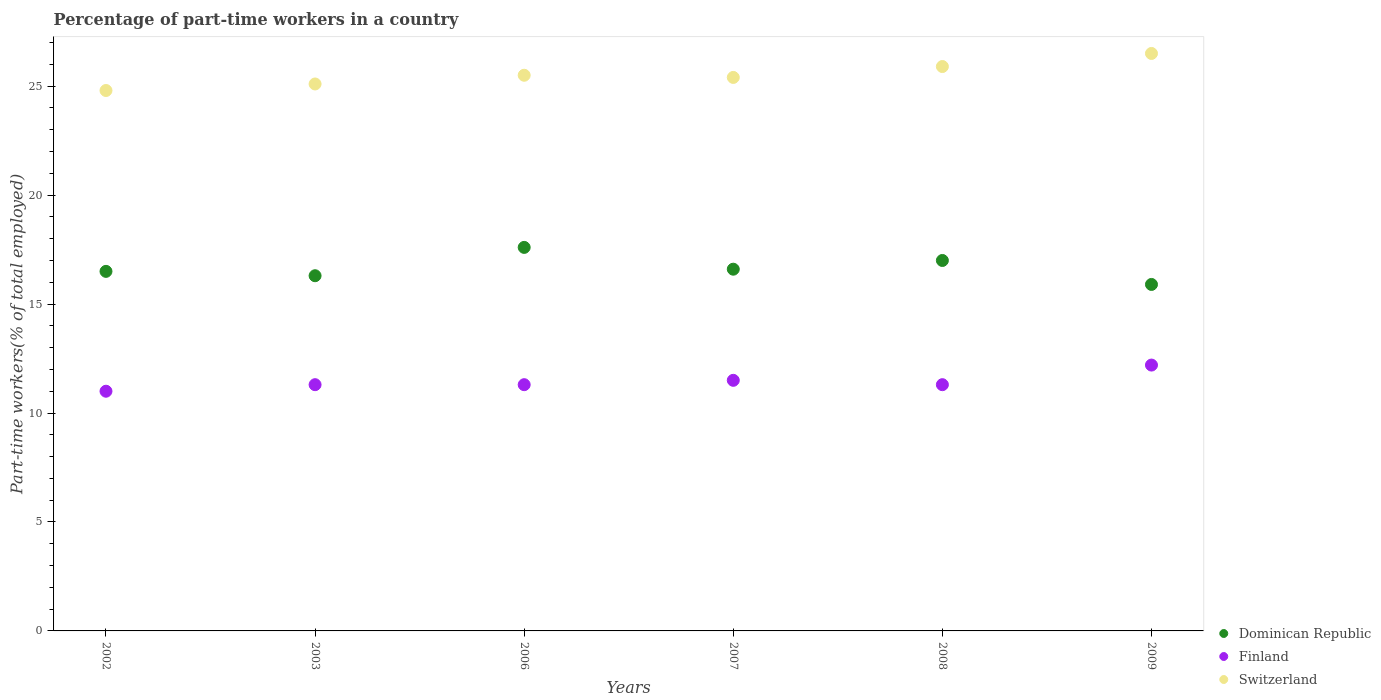Is the number of dotlines equal to the number of legend labels?
Offer a terse response. Yes. What is the percentage of part-time workers in Finland in 2003?
Give a very brief answer. 11.3. Across all years, what is the minimum percentage of part-time workers in Dominican Republic?
Your response must be concise. 15.9. In which year was the percentage of part-time workers in Switzerland maximum?
Keep it short and to the point. 2009. What is the total percentage of part-time workers in Finland in the graph?
Keep it short and to the point. 68.6. What is the difference between the percentage of part-time workers in Dominican Republic in 2003 and that in 2007?
Your answer should be very brief. -0.3. What is the difference between the percentage of part-time workers in Finland in 2002 and the percentage of part-time workers in Switzerland in 2008?
Your answer should be compact. -14.9. What is the average percentage of part-time workers in Finland per year?
Make the answer very short. 11.43. In the year 2003, what is the difference between the percentage of part-time workers in Dominican Republic and percentage of part-time workers in Switzerland?
Keep it short and to the point. -8.8. In how many years, is the percentage of part-time workers in Dominican Republic greater than 18 %?
Provide a succinct answer. 0. What is the ratio of the percentage of part-time workers in Finland in 2002 to that in 2003?
Offer a very short reply. 0.97. What is the difference between the highest and the second highest percentage of part-time workers in Dominican Republic?
Your answer should be very brief. 0.6. What is the difference between the highest and the lowest percentage of part-time workers in Switzerland?
Make the answer very short. 1.7. Is the percentage of part-time workers in Switzerland strictly greater than the percentage of part-time workers in Finland over the years?
Offer a terse response. Yes. Is the percentage of part-time workers in Dominican Republic strictly less than the percentage of part-time workers in Switzerland over the years?
Keep it short and to the point. Yes. Are the values on the major ticks of Y-axis written in scientific E-notation?
Your answer should be compact. No. Does the graph contain grids?
Your answer should be compact. No. How many legend labels are there?
Ensure brevity in your answer.  3. How are the legend labels stacked?
Your response must be concise. Vertical. What is the title of the graph?
Provide a succinct answer. Percentage of part-time workers in a country. Does "Senegal" appear as one of the legend labels in the graph?
Your response must be concise. No. What is the label or title of the X-axis?
Provide a succinct answer. Years. What is the label or title of the Y-axis?
Provide a short and direct response. Part-time workers(% of total employed). What is the Part-time workers(% of total employed) in Dominican Republic in 2002?
Give a very brief answer. 16.5. What is the Part-time workers(% of total employed) of Switzerland in 2002?
Give a very brief answer. 24.8. What is the Part-time workers(% of total employed) of Dominican Republic in 2003?
Offer a terse response. 16.3. What is the Part-time workers(% of total employed) of Finland in 2003?
Your answer should be very brief. 11.3. What is the Part-time workers(% of total employed) in Switzerland in 2003?
Give a very brief answer. 25.1. What is the Part-time workers(% of total employed) in Dominican Republic in 2006?
Your answer should be compact. 17.6. What is the Part-time workers(% of total employed) in Finland in 2006?
Make the answer very short. 11.3. What is the Part-time workers(% of total employed) in Dominican Republic in 2007?
Your answer should be compact. 16.6. What is the Part-time workers(% of total employed) of Finland in 2007?
Give a very brief answer. 11.5. What is the Part-time workers(% of total employed) of Switzerland in 2007?
Your response must be concise. 25.4. What is the Part-time workers(% of total employed) in Dominican Republic in 2008?
Provide a short and direct response. 17. What is the Part-time workers(% of total employed) in Finland in 2008?
Give a very brief answer. 11.3. What is the Part-time workers(% of total employed) of Switzerland in 2008?
Give a very brief answer. 25.9. What is the Part-time workers(% of total employed) in Dominican Republic in 2009?
Ensure brevity in your answer.  15.9. What is the Part-time workers(% of total employed) in Finland in 2009?
Your answer should be compact. 12.2. Across all years, what is the maximum Part-time workers(% of total employed) of Dominican Republic?
Provide a short and direct response. 17.6. Across all years, what is the maximum Part-time workers(% of total employed) of Finland?
Provide a succinct answer. 12.2. Across all years, what is the minimum Part-time workers(% of total employed) of Dominican Republic?
Your answer should be very brief. 15.9. Across all years, what is the minimum Part-time workers(% of total employed) in Switzerland?
Offer a terse response. 24.8. What is the total Part-time workers(% of total employed) in Dominican Republic in the graph?
Offer a terse response. 99.9. What is the total Part-time workers(% of total employed) of Finland in the graph?
Make the answer very short. 68.6. What is the total Part-time workers(% of total employed) of Switzerland in the graph?
Offer a terse response. 153.2. What is the difference between the Part-time workers(% of total employed) in Dominican Republic in 2002 and that in 2003?
Your response must be concise. 0.2. What is the difference between the Part-time workers(% of total employed) of Finland in 2002 and that in 2006?
Ensure brevity in your answer.  -0.3. What is the difference between the Part-time workers(% of total employed) in Finland in 2002 and that in 2007?
Your response must be concise. -0.5. What is the difference between the Part-time workers(% of total employed) of Switzerland in 2002 and that in 2007?
Keep it short and to the point. -0.6. What is the difference between the Part-time workers(% of total employed) of Dominican Republic in 2002 and that in 2008?
Offer a very short reply. -0.5. What is the difference between the Part-time workers(% of total employed) in Switzerland in 2002 and that in 2008?
Give a very brief answer. -1.1. What is the difference between the Part-time workers(% of total employed) of Dominican Republic in 2002 and that in 2009?
Ensure brevity in your answer.  0.6. What is the difference between the Part-time workers(% of total employed) in Finland in 2003 and that in 2006?
Keep it short and to the point. 0. What is the difference between the Part-time workers(% of total employed) of Switzerland in 2003 and that in 2006?
Your response must be concise. -0.4. What is the difference between the Part-time workers(% of total employed) in Dominican Republic in 2003 and that in 2008?
Give a very brief answer. -0.7. What is the difference between the Part-time workers(% of total employed) in Finland in 2003 and that in 2009?
Your response must be concise. -0.9. What is the difference between the Part-time workers(% of total employed) in Switzerland in 2003 and that in 2009?
Your answer should be compact. -1.4. What is the difference between the Part-time workers(% of total employed) in Dominican Republic in 2006 and that in 2007?
Keep it short and to the point. 1. What is the difference between the Part-time workers(% of total employed) in Switzerland in 2006 and that in 2007?
Offer a terse response. 0.1. What is the difference between the Part-time workers(% of total employed) of Switzerland in 2006 and that in 2008?
Your response must be concise. -0.4. What is the difference between the Part-time workers(% of total employed) of Switzerland in 2006 and that in 2009?
Ensure brevity in your answer.  -1. What is the difference between the Part-time workers(% of total employed) in Finland in 2007 and that in 2008?
Provide a short and direct response. 0.2. What is the difference between the Part-time workers(% of total employed) of Switzerland in 2007 and that in 2008?
Make the answer very short. -0.5. What is the difference between the Part-time workers(% of total employed) in Dominican Republic in 2007 and that in 2009?
Offer a terse response. 0.7. What is the difference between the Part-time workers(% of total employed) in Finland in 2007 and that in 2009?
Ensure brevity in your answer.  -0.7. What is the difference between the Part-time workers(% of total employed) of Switzerland in 2007 and that in 2009?
Offer a terse response. -1.1. What is the difference between the Part-time workers(% of total employed) in Dominican Republic in 2008 and that in 2009?
Provide a short and direct response. 1.1. What is the difference between the Part-time workers(% of total employed) in Switzerland in 2008 and that in 2009?
Provide a succinct answer. -0.6. What is the difference between the Part-time workers(% of total employed) of Dominican Republic in 2002 and the Part-time workers(% of total employed) of Finland in 2003?
Offer a very short reply. 5.2. What is the difference between the Part-time workers(% of total employed) of Finland in 2002 and the Part-time workers(% of total employed) of Switzerland in 2003?
Ensure brevity in your answer.  -14.1. What is the difference between the Part-time workers(% of total employed) in Dominican Republic in 2002 and the Part-time workers(% of total employed) in Switzerland in 2006?
Your answer should be very brief. -9. What is the difference between the Part-time workers(% of total employed) of Finland in 2002 and the Part-time workers(% of total employed) of Switzerland in 2006?
Ensure brevity in your answer.  -14.5. What is the difference between the Part-time workers(% of total employed) in Dominican Republic in 2002 and the Part-time workers(% of total employed) in Switzerland in 2007?
Your answer should be very brief. -8.9. What is the difference between the Part-time workers(% of total employed) in Finland in 2002 and the Part-time workers(% of total employed) in Switzerland in 2007?
Your answer should be compact. -14.4. What is the difference between the Part-time workers(% of total employed) in Dominican Republic in 2002 and the Part-time workers(% of total employed) in Finland in 2008?
Ensure brevity in your answer.  5.2. What is the difference between the Part-time workers(% of total employed) of Dominican Republic in 2002 and the Part-time workers(% of total employed) of Switzerland in 2008?
Ensure brevity in your answer.  -9.4. What is the difference between the Part-time workers(% of total employed) in Finland in 2002 and the Part-time workers(% of total employed) in Switzerland in 2008?
Keep it short and to the point. -14.9. What is the difference between the Part-time workers(% of total employed) in Dominican Republic in 2002 and the Part-time workers(% of total employed) in Switzerland in 2009?
Offer a very short reply. -10. What is the difference between the Part-time workers(% of total employed) of Finland in 2002 and the Part-time workers(% of total employed) of Switzerland in 2009?
Keep it short and to the point. -15.5. What is the difference between the Part-time workers(% of total employed) of Dominican Republic in 2003 and the Part-time workers(% of total employed) of Switzerland in 2006?
Your answer should be very brief. -9.2. What is the difference between the Part-time workers(% of total employed) of Dominican Republic in 2003 and the Part-time workers(% of total employed) of Switzerland in 2007?
Your response must be concise. -9.1. What is the difference between the Part-time workers(% of total employed) in Finland in 2003 and the Part-time workers(% of total employed) in Switzerland in 2007?
Give a very brief answer. -14.1. What is the difference between the Part-time workers(% of total employed) in Finland in 2003 and the Part-time workers(% of total employed) in Switzerland in 2008?
Your answer should be compact. -14.6. What is the difference between the Part-time workers(% of total employed) in Dominican Republic in 2003 and the Part-time workers(% of total employed) in Finland in 2009?
Provide a short and direct response. 4.1. What is the difference between the Part-time workers(% of total employed) in Dominican Republic in 2003 and the Part-time workers(% of total employed) in Switzerland in 2009?
Provide a short and direct response. -10.2. What is the difference between the Part-time workers(% of total employed) in Finland in 2003 and the Part-time workers(% of total employed) in Switzerland in 2009?
Make the answer very short. -15.2. What is the difference between the Part-time workers(% of total employed) of Dominican Republic in 2006 and the Part-time workers(% of total employed) of Finland in 2007?
Offer a terse response. 6.1. What is the difference between the Part-time workers(% of total employed) of Finland in 2006 and the Part-time workers(% of total employed) of Switzerland in 2007?
Give a very brief answer. -14.1. What is the difference between the Part-time workers(% of total employed) of Dominican Republic in 2006 and the Part-time workers(% of total employed) of Switzerland in 2008?
Your response must be concise. -8.3. What is the difference between the Part-time workers(% of total employed) in Finland in 2006 and the Part-time workers(% of total employed) in Switzerland in 2008?
Your answer should be very brief. -14.6. What is the difference between the Part-time workers(% of total employed) of Dominican Republic in 2006 and the Part-time workers(% of total employed) of Finland in 2009?
Offer a terse response. 5.4. What is the difference between the Part-time workers(% of total employed) in Dominican Republic in 2006 and the Part-time workers(% of total employed) in Switzerland in 2009?
Your response must be concise. -8.9. What is the difference between the Part-time workers(% of total employed) of Finland in 2006 and the Part-time workers(% of total employed) of Switzerland in 2009?
Provide a succinct answer. -15.2. What is the difference between the Part-time workers(% of total employed) of Dominican Republic in 2007 and the Part-time workers(% of total employed) of Finland in 2008?
Your answer should be compact. 5.3. What is the difference between the Part-time workers(% of total employed) in Finland in 2007 and the Part-time workers(% of total employed) in Switzerland in 2008?
Offer a terse response. -14.4. What is the difference between the Part-time workers(% of total employed) of Dominican Republic in 2007 and the Part-time workers(% of total employed) of Finland in 2009?
Give a very brief answer. 4.4. What is the difference between the Part-time workers(% of total employed) in Finland in 2007 and the Part-time workers(% of total employed) in Switzerland in 2009?
Ensure brevity in your answer.  -15. What is the difference between the Part-time workers(% of total employed) in Dominican Republic in 2008 and the Part-time workers(% of total employed) in Finland in 2009?
Ensure brevity in your answer.  4.8. What is the difference between the Part-time workers(% of total employed) of Dominican Republic in 2008 and the Part-time workers(% of total employed) of Switzerland in 2009?
Your answer should be compact. -9.5. What is the difference between the Part-time workers(% of total employed) of Finland in 2008 and the Part-time workers(% of total employed) of Switzerland in 2009?
Ensure brevity in your answer.  -15.2. What is the average Part-time workers(% of total employed) of Dominican Republic per year?
Offer a very short reply. 16.65. What is the average Part-time workers(% of total employed) of Finland per year?
Ensure brevity in your answer.  11.43. What is the average Part-time workers(% of total employed) of Switzerland per year?
Your answer should be compact. 25.53. In the year 2006, what is the difference between the Part-time workers(% of total employed) in Finland and Part-time workers(% of total employed) in Switzerland?
Give a very brief answer. -14.2. In the year 2007, what is the difference between the Part-time workers(% of total employed) in Dominican Republic and Part-time workers(% of total employed) in Finland?
Provide a succinct answer. 5.1. In the year 2008, what is the difference between the Part-time workers(% of total employed) of Finland and Part-time workers(% of total employed) of Switzerland?
Offer a terse response. -14.6. In the year 2009, what is the difference between the Part-time workers(% of total employed) in Finland and Part-time workers(% of total employed) in Switzerland?
Give a very brief answer. -14.3. What is the ratio of the Part-time workers(% of total employed) of Dominican Republic in 2002 to that in 2003?
Offer a terse response. 1.01. What is the ratio of the Part-time workers(% of total employed) of Finland in 2002 to that in 2003?
Your response must be concise. 0.97. What is the ratio of the Part-time workers(% of total employed) of Switzerland in 2002 to that in 2003?
Ensure brevity in your answer.  0.99. What is the ratio of the Part-time workers(% of total employed) in Finland in 2002 to that in 2006?
Provide a succinct answer. 0.97. What is the ratio of the Part-time workers(% of total employed) in Switzerland in 2002 to that in 2006?
Ensure brevity in your answer.  0.97. What is the ratio of the Part-time workers(% of total employed) of Dominican Republic in 2002 to that in 2007?
Offer a terse response. 0.99. What is the ratio of the Part-time workers(% of total employed) of Finland in 2002 to that in 2007?
Ensure brevity in your answer.  0.96. What is the ratio of the Part-time workers(% of total employed) in Switzerland in 2002 to that in 2007?
Provide a succinct answer. 0.98. What is the ratio of the Part-time workers(% of total employed) in Dominican Republic in 2002 to that in 2008?
Keep it short and to the point. 0.97. What is the ratio of the Part-time workers(% of total employed) of Finland in 2002 to that in 2008?
Offer a terse response. 0.97. What is the ratio of the Part-time workers(% of total employed) of Switzerland in 2002 to that in 2008?
Provide a succinct answer. 0.96. What is the ratio of the Part-time workers(% of total employed) of Dominican Republic in 2002 to that in 2009?
Offer a very short reply. 1.04. What is the ratio of the Part-time workers(% of total employed) in Finland in 2002 to that in 2009?
Keep it short and to the point. 0.9. What is the ratio of the Part-time workers(% of total employed) of Switzerland in 2002 to that in 2009?
Offer a very short reply. 0.94. What is the ratio of the Part-time workers(% of total employed) of Dominican Republic in 2003 to that in 2006?
Provide a succinct answer. 0.93. What is the ratio of the Part-time workers(% of total employed) of Switzerland in 2003 to that in 2006?
Your response must be concise. 0.98. What is the ratio of the Part-time workers(% of total employed) of Dominican Republic in 2003 to that in 2007?
Offer a very short reply. 0.98. What is the ratio of the Part-time workers(% of total employed) of Finland in 2003 to that in 2007?
Offer a terse response. 0.98. What is the ratio of the Part-time workers(% of total employed) of Dominican Republic in 2003 to that in 2008?
Your answer should be very brief. 0.96. What is the ratio of the Part-time workers(% of total employed) in Finland in 2003 to that in 2008?
Provide a short and direct response. 1. What is the ratio of the Part-time workers(% of total employed) in Switzerland in 2003 to that in 2008?
Make the answer very short. 0.97. What is the ratio of the Part-time workers(% of total employed) of Dominican Republic in 2003 to that in 2009?
Offer a terse response. 1.03. What is the ratio of the Part-time workers(% of total employed) in Finland in 2003 to that in 2009?
Your response must be concise. 0.93. What is the ratio of the Part-time workers(% of total employed) in Switzerland in 2003 to that in 2009?
Your answer should be very brief. 0.95. What is the ratio of the Part-time workers(% of total employed) of Dominican Republic in 2006 to that in 2007?
Your answer should be compact. 1.06. What is the ratio of the Part-time workers(% of total employed) of Finland in 2006 to that in 2007?
Your answer should be very brief. 0.98. What is the ratio of the Part-time workers(% of total employed) of Dominican Republic in 2006 to that in 2008?
Your answer should be compact. 1.04. What is the ratio of the Part-time workers(% of total employed) of Switzerland in 2006 to that in 2008?
Give a very brief answer. 0.98. What is the ratio of the Part-time workers(% of total employed) in Dominican Republic in 2006 to that in 2009?
Make the answer very short. 1.11. What is the ratio of the Part-time workers(% of total employed) in Finland in 2006 to that in 2009?
Offer a terse response. 0.93. What is the ratio of the Part-time workers(% of total employed) in Switzerland in 2006 to that in 2009?
Keep it short and to the point. 0.96. What is the ratio of the Part-time workers(% of total employed) in Dominican Republic in 2007 to that in 2008?
Keep it short and to the point. 0.98. What is the ratio of the Part-time workers(% of total employed) of Finland in 2007 to that in 2008?
Ensure brevity in your answer.  1.02. What is the ratio of the Part-time workers(% of total employed) of Switzerland in 2007 to that in 2008?
Offer a terse response. 0.98. What is the ratio of the Part-time workers(% of total employed) of Dominican Republic in 2007 to that in 2009?
Make the answer very short. 1.04. What is the ratio of the Part-time workers(% of total employed) in Finland in 2007 to that in 2009?
Your answer should be very brief. 0.94. What is the ratio of the Part-time workers(% of total employed) in Switzerland in 2007 to that in 2009?
Your response must be concise. 0.96. What is the ratio of the Part-time workers(% of total employed) in Dominican Republic in 2008 to that in 2009?
Your response must be concise. 1.07. What is the ratio of the Part-time workers(% of total employed) of Finland in 2008 to that in 2009?
Provide a short and direct response. 0.93. What is the ratio of the Part-time workers(% of total employed) in Switzerland in 2008 to that in 2009?
Your answer should be very brief. 0.98. What is the difference between the highest and the second highest Part-time workers(% of total employed) of Finland?
Provide a short and direct response. 0.7. What is the difference between the highest and the second highest Part-time workers(% of total employed) in Switzerland?
Your response must be concise. 0.6. What is the difference between the highest and the lowest Part-time workers(% of total employed) in Finland?
Your answer should be very brief. 1.2. What is the difference between the highest and the lowest Part-time workers(% of total employed) of Switzerland?
Provide a short and direct response. 1.7. 